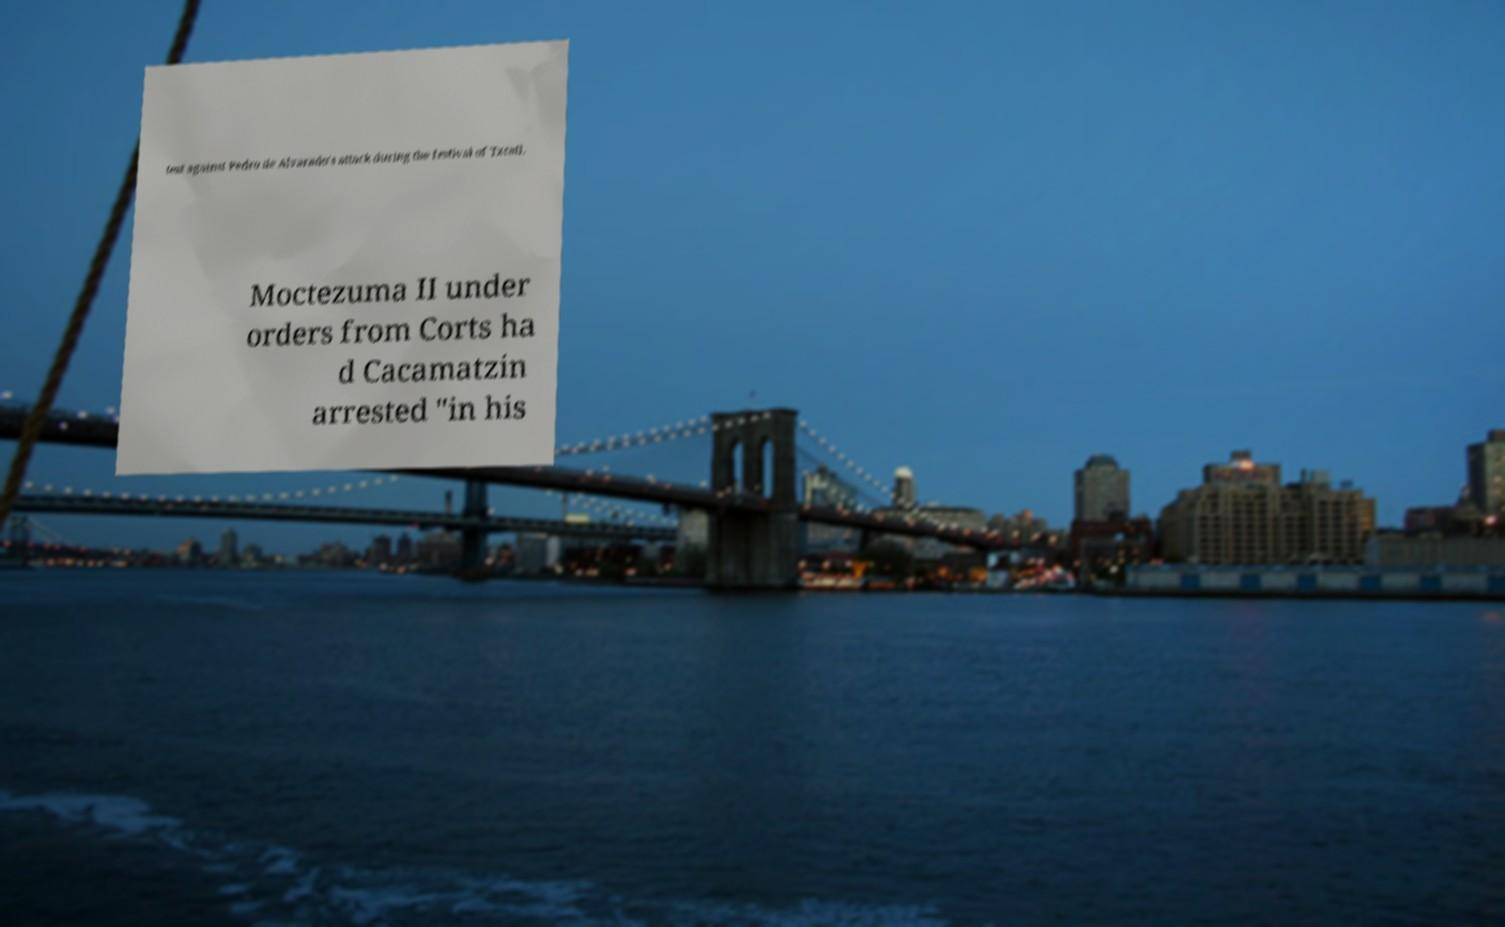What messages or text are displayed in this image? I need them in a readable, typed format. test against Pedro de Alvarado's attack during the festival of Txcatl. Moctezuma II under orders from Corts ha d Cacamatzin arrested "in his 